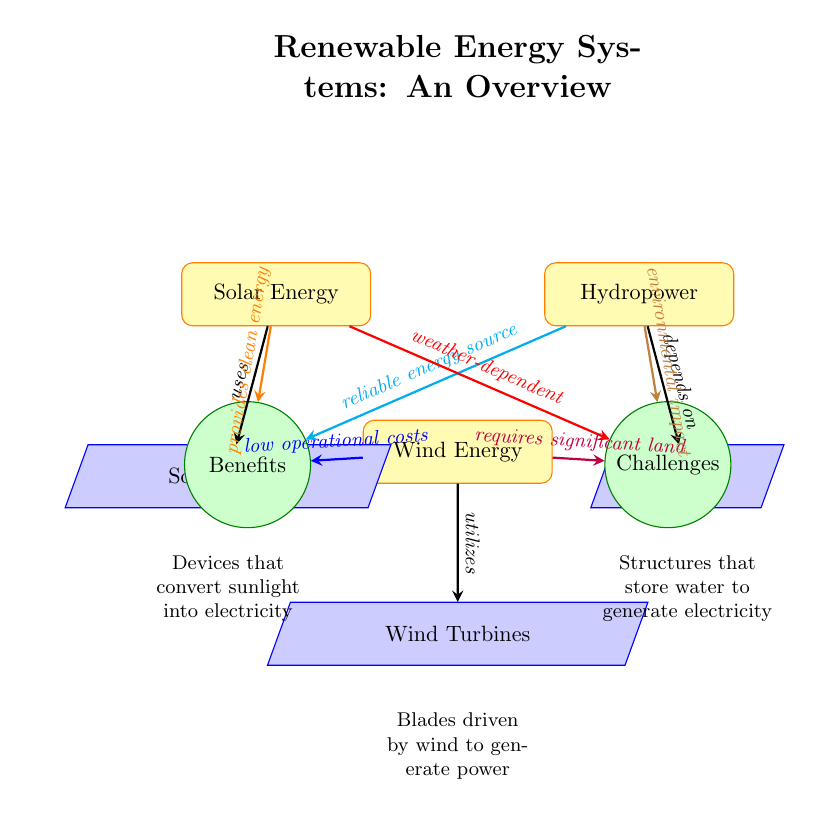What are the three types of renewable energy sources illustrated in the diagram? The diagram clearly presents three types of renewable energy sources: Solar Energy, Wind Energy, and Hydropower. Each energy source is represented by a distinct node in the visualization.
Answer: Solar Energy, Wind Energy, Hydropower Which technology is associated with solar energy? The diagram connects Solar Energy to Solar Panels. This indicates that the technology linked to solar energy is represented below the Solar Energy node.
Answer: Solar Panels What benefit is specifically highlighted for wind energy? The arrow leading from Wind Energy to the Benefits aspect indicates that it has low operational costs as a highlighted benefit, as noted in the labeling on the connecting arrow.
Answer: low operational costs What challenge is associated with hydropower? A connecting arrow from Hydropower to the Challenges aspect reveals that environmental impact is discussed as a challenge associated with this energy source. This is clearly indicated by the label on the arrow.
Answer: environmental impact How many types of technologies are depicted in the diagram? The diagram includes three technologies: Solar Panels, Wind Turbines, and Dams. These are shown as tech nodes connecting from their respective energy sources, leading to the conclusion of three technologies.
Answer: 3 What does the arrow from solar energy to benefits indicate? The arrow signifies that solar energy provides clean energy as a benefit, as specified by the label on the connecting arrow. This indicates a positive attribute of solar energy.
Answer: provides clean energy Which energy source utilizes turbines? The diagram shows that Wind Energy is associated with Wind Turbines, as indicated by the arrow leading from Wind Energy to the respective technology node.
Answer: Wind Energy What is the relationship between hydropower and dams? According to the diagram, Hydropower depends on Dams, as shown by the connecting arrow that specifies the relationship between these two nodes.
Answer: depends on 